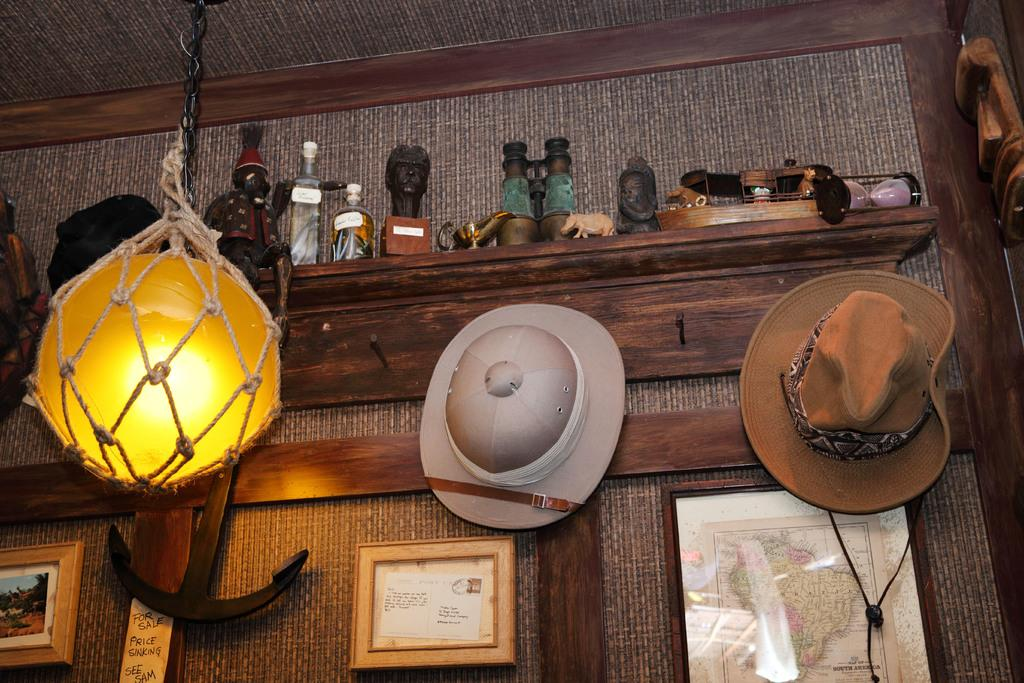What is present on the wall in the image? The wall has photo frames and hats in the image. What can be seen on the shelf in the image? There are various items on the shelf in the image. How is the room illuminated in the image? A light is hanging from the ceiling in the image. What color is the paint on the wall in the image? The provided facts do not mention the color of the paint on the wall, so we cannot determine the color from the image. 